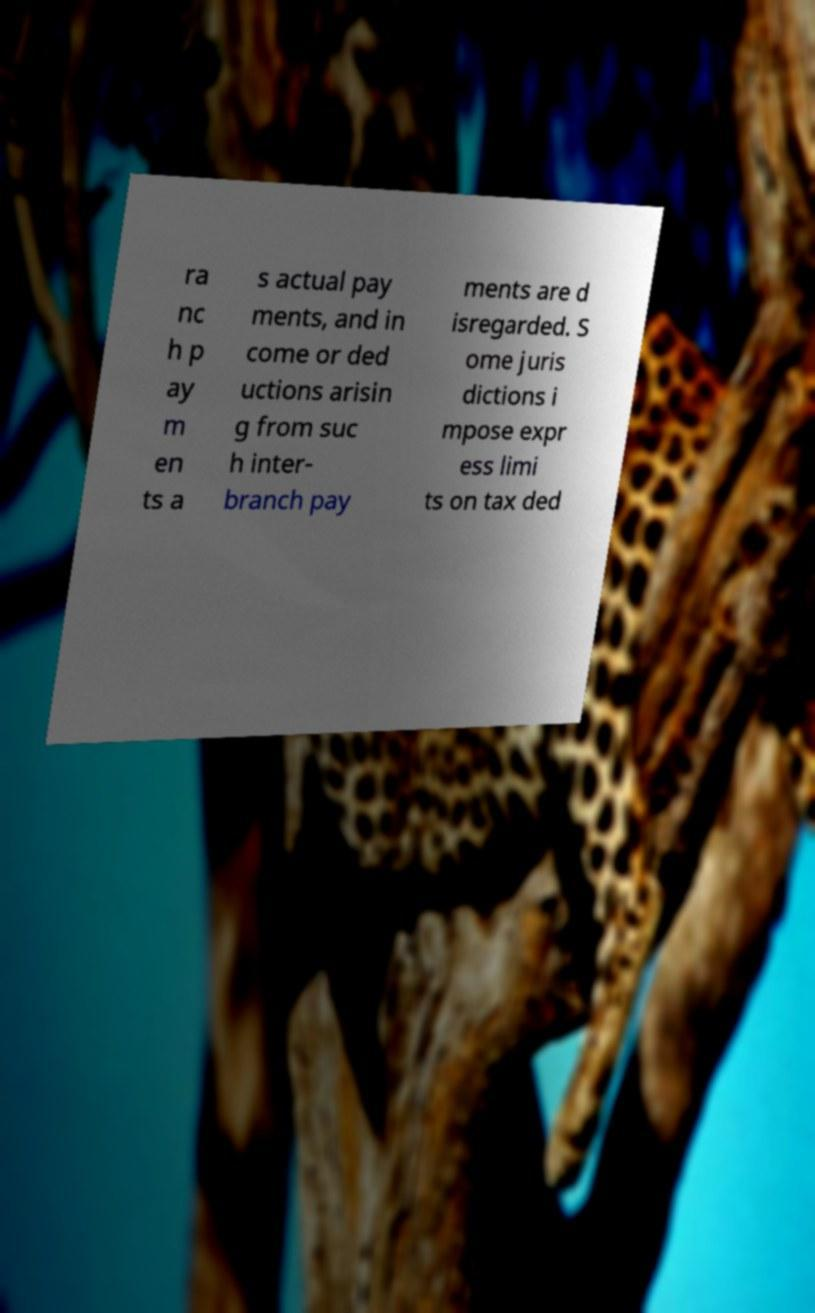Can you read and provide the text displayed in the image?This photo seems to have some interesting text. Can you extract and type it out for me? ra nc h p ay m en ts a s actual pay ments, and in come or ded uctions arisin g from suc h inter- branch pay ments are d isregarded. S ome juris dictions i mpose expr ess limi ts on tax ded 